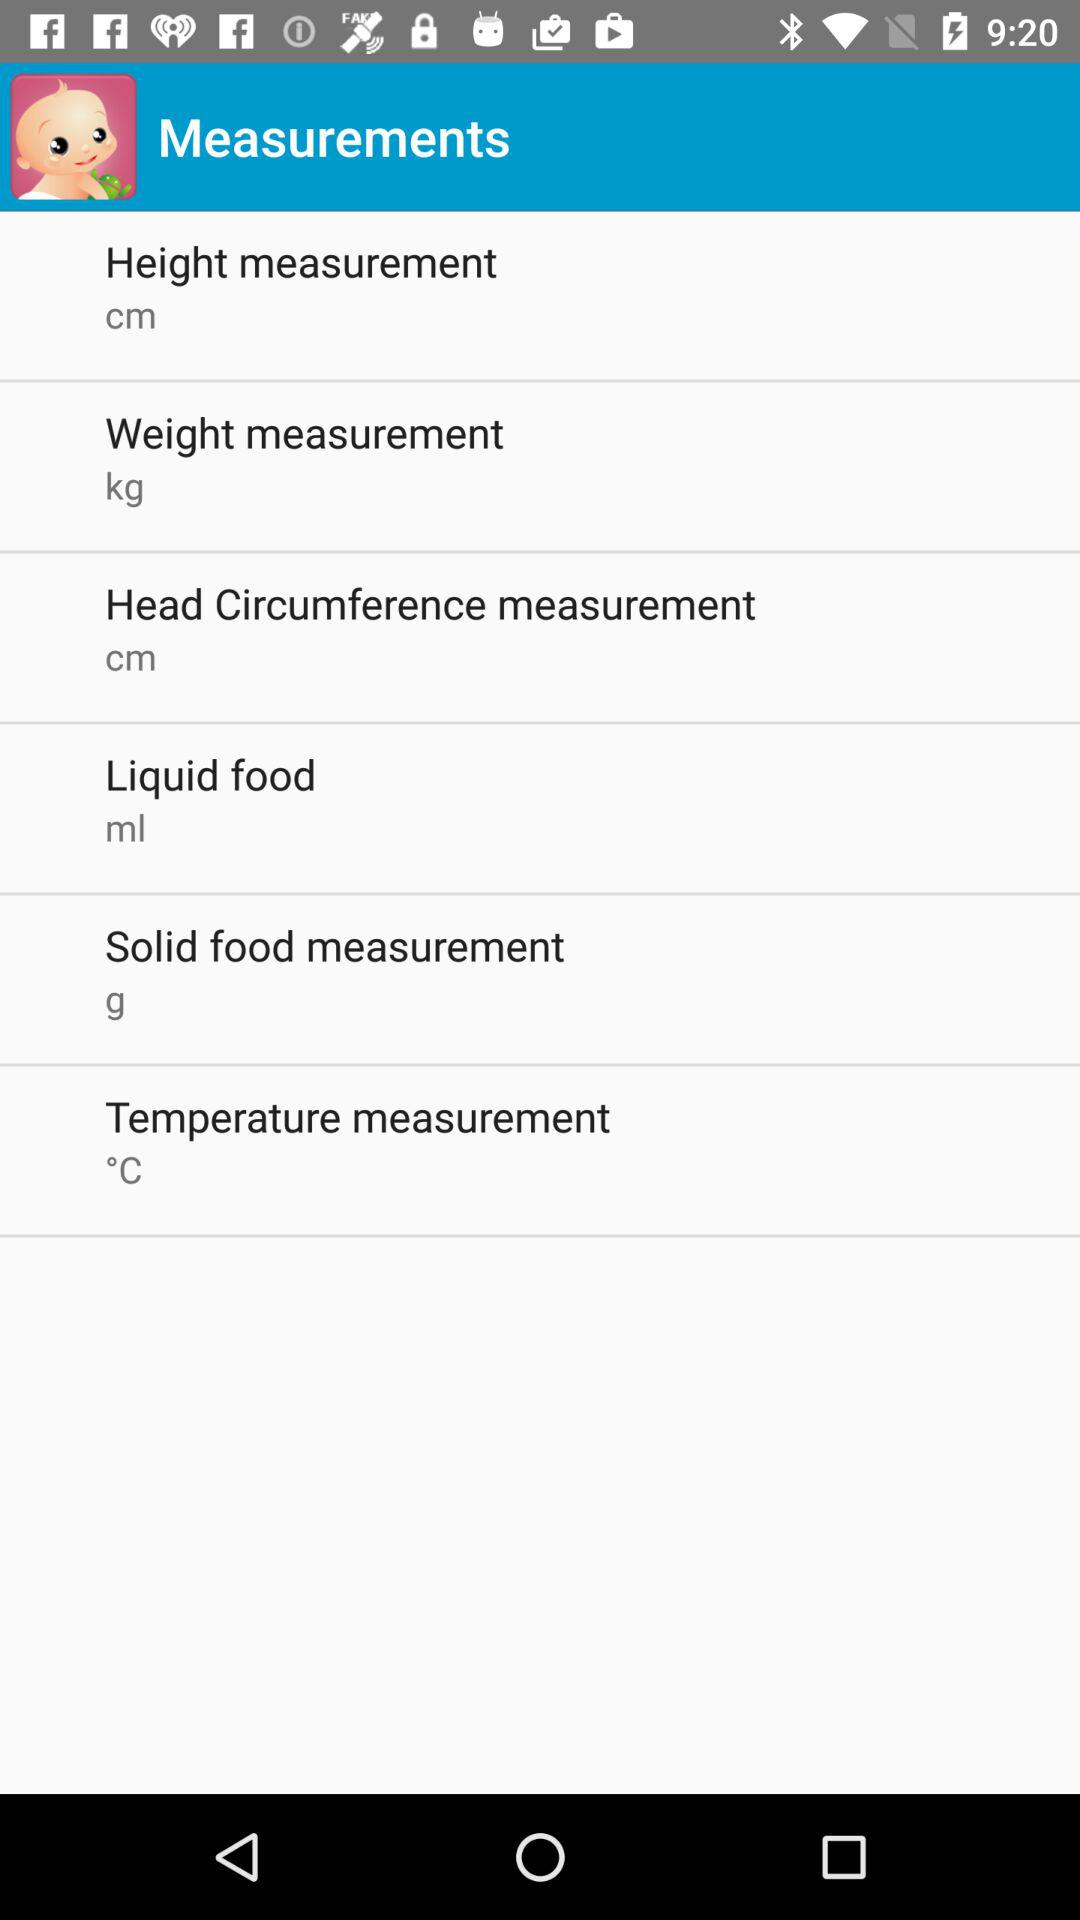How many measurements are there in total?
Answer the question using a single word or phrase. 6 